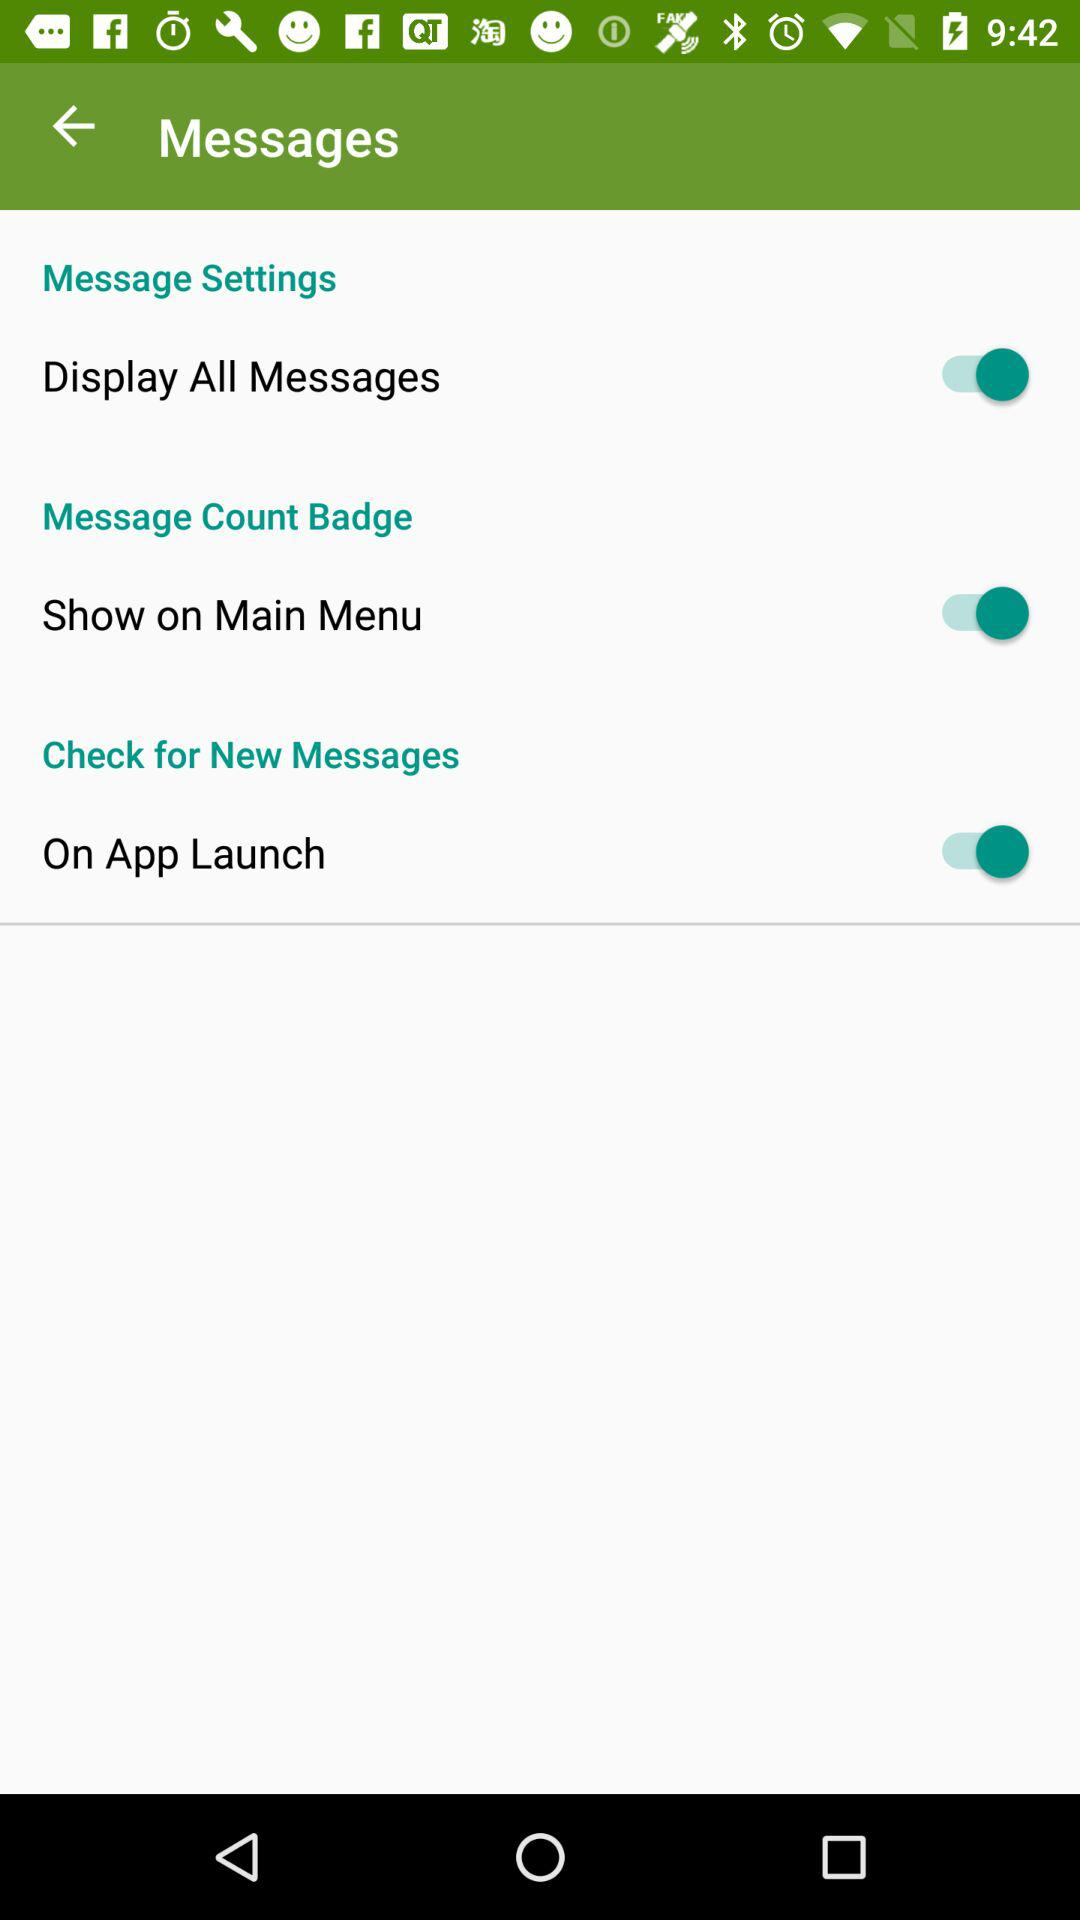What is the status of the "Display All Messages"? The status is "on". 